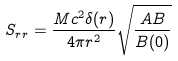<formula> <loc_0><loc_0><loc_500><loc_500>S _ { r r } = \frac { M c ^ { 2 } \delta ( r ) } { 4 \pi r ^ { 2 } } \sqrt { \frac { A B } { B ( 0 ) } }</formula> 